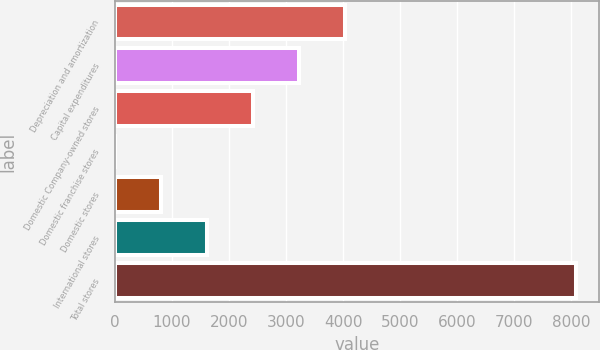<chart> <loc_0><loc_0><loc_500><loc_500><bar_chart><fcel>Depreciation and amortization<fcel>Capital expenditures<fcel>Domestic Company-owned stores<fcel>Domestic franchise stores<fcel>Domestic stores<fcel>International stores<fcel>Total stores<nl><fcel>4041.8<fcel>3234.36<fcel>2426.92<fcel>4.6<fcel>812.04<fcel>1619.48<fcel>8079<nl></chart> 